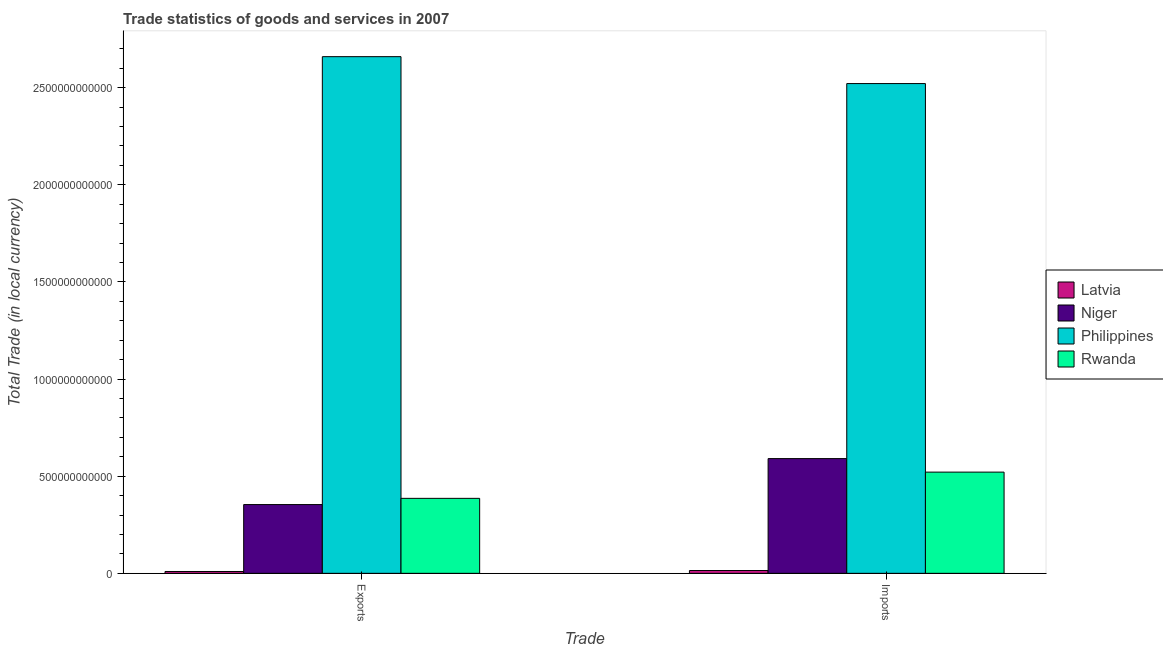How many groups of bars are there?
Your answer should be very brief. 2. Are the number of bars per tick equal to the number of legend labels?
Provide a short and direct response. Yes. How many bars are there on the 1st tick from the right?
Ensure brevity in your answer.  4. What is the label of the 1st group of bars from the left?
Make the answer very short. Exports. What is the export of goods and services in Philippines?
Your answer should be very brief. 2.66e+12. Across all countries, what is the maximum imports of goods and services?
Offer a very short reply. 2.52e+12. Across all countries, what is the minimum imports of goods and services?
Your answer should be very brief. 1.44e+1. In which country was the export of goods and services minimum?
Your answer should be compact. Latvia. What is the total export of goods and services in the graph?
Give a very brief answer. 3.41e+12. What is the difference between the export of goods and services in Latvia and that in Rwanda?
Keep it short and to the point. -3.76e+11. What is the difference between the imports of goods and services in Niger and the export of goods and services in Philippines?
Provide a short and direct response. -2.07e+12. What is the average export of goods and services per country?
Your answer should be compact. 8.52e+11. What is the difference between the imports of goods and services and export of goods and services in Rwanda?
Your answer should be compact. 1.35e+11. In how many countries, is the imports of goods and services greater than 1100000000000 LCU?
Ensure brevity in your answer.  1. What is the ratio of the export of goods and services in Philippines to that in Niger?
Keep it short and to the point. 7.51. Is the export of goods and services in Rwanda less than that in Niger?
Give a very brief answer. No. What does the 4th bar from the left in Exports represents?
Your answer should be compact. Rwanda. What does the 3rd bar from the right in Exports represents?
Offer a very short reply. Niger. What is the difference between two consecutive major ticks on the Y-axis?
Your response must be concise. 5.00e+11. Are the values on the major ticks of Y-axis written in scientific E-notation?
Ensure brevity in your answer.  No. Does the graph contain any zero values?
Provide a short and direct response. No. Where does the legend appear in the graph?
Provide a short and direct response. Center right. How many legend labels are there?
Keep it short and to the point. 4. How are the legend labels stacked?
Ensure brevity in your answer.  Vertical. What is the title of the graph?
Offer a very short reply. Trade statistics of goods and services in 2007. What is the label or title of the X-axis?
Offer a very short reply. Trade. What is the label or title of the Y-axis?
Offer a very short reply. Total Trade (in local currency). What is the Total Trade (in local currency) of Latvia in Exports?
Make the answer very short. 9.51e+09. What is the Total Trade (in local currency) in Niger in Exports?
Offer a very short reply. 3.54e+11. What is the Total Trade (in local currency) of Philippines in Exports?
Ensure brevity in your answer.  2.66e+12. What is the Total Trade (in local currency) in Rwanda in Exports?
Make the answer very short. 3.86e+11. What is the Total Trade (in local currency) of Latvia in Imports?
Ensure brevity in your answer.  1.44e+1. What is the Total Trade (in local currency) of Niger in Imports?
Provide a short and direct response. 5.91e+11. What is the Total Trade (in local currency) of Philippines in Imports?
Offer a terse response. 2.52e+12. What is the Total Trade (in local currency) of Rwanda in Imports?
Ensure brevity in your answer.  5.21e+11. Across all Trade, what is the maximum Total Trade (in local currency) in Latvia?
Keep it short and to the point. 1.44e+1. Across all Trade, what is the maximum Total Trade (in local currency) in Niger?
Your answer should be compact. 5.91e+11. Across all Trade, what is the maximum Total Trade (in local currency) of Philippines?
Ensure brevity in your answer.  2.66e+12. Across all Trade, what is the maximum Total Trade (in local currency) of Rwanda?
Give a very brief answer. 5.21e+11. Across all Trade, what is the minimum Total Trade (in local currency) of Latvia?
Give a very brief answer. 9.51e+09. Across all Trade, what is the minimum Total Trade (in local currency) in Niger?
Ensure brevity in your answer.  3.54e+11. Across all Trade, what is the minimum Total Trade (in local currency) of Philippines?
Your response must be concise. 2.52e+12. Across all Trade, what is the minimum Total Trade (in local currency) in Rwanda?
Provide a succinct answer. 3.86e+11. What is the total Total Trade (in local currency) in Latvia in the graph?
Offer a very short reply. 2.39e+1. What is the total Total Trade (in local currency) in Niger in the graph?
Provide a succinct answer. 9.45e+11. What is the total Total Trade (in local currency) of Philippines in the graph?
Your answer should be very brief. 5.18e+12. What is the total Total Trade (in local currency) of Rwanda in the graph?
Give a very brief answer. 9.07e+11. What is the difference between the Total Trade (in local currency) in Latvia in Exports and that in Imports?
Provide a short and direct response. -4.92e+09. What is the difference between the Total Trade (in local currency) in Niger in Exports and that in Imports?
Keep it short and to the point. -2.37e+11. What is the difference between the Total Trade (in local currency) in Philippines in Exports and that in Imports?
Provide a succinct answer. 1.39e+11. What is the difference between the Total Trade (in local currency) in Rwanda in Exports and that in Imports?
Provide a short and direct response. -1.35e+11. What is the difference between the Total Trade (in local currency) of Latvia in Exports and the Total Trade (in local currency) of Niger in Imports?
Provide a succinct answer. -5.81e+11. What is the difference between the Total Trade (in local currency) of Latvia in Exports and the Total Trade (in local currency) of Philippines in Imports?
Your answer should be very brief. -2.51e+12. What is the difference between the Total Trade (in local currency) of Latvia in Exports and the Total Trade (in local currency) of Rwanda in Imports?
Ensure brevity in your answer.  -5.11e+11. What is the difference between the Total Trade (in local currency) of Niger in Exports and the Total Trade (in local currency) of Philippines in Imports?
Make the answer very short. -2.17e+12. What is the difference between the Total Trade (in local currency) of Niger in Exports and the Total Trade (in local currency) of Rwanda in Imports?
Offer a very short reply. -1.67e+11. What is the difference between the Total Trade (in local currency) of Philippines in Exports and the Total Trade (in local currency) of Rwanda in Imports?
Your answer should be very brief. 2.14e+12. What is the average Total Trade (in local currency) of Latvia per Trade?
Your response must be concise. 1.20e+1. What is the average Total Trade (in local currency) of Niger per Trade?
Give a very brief answer. 4.72e+11. What is the average Total Trade (in local currency) of Philippines per Trade?
Your answer should be compact. 2.59e+12. What is the average Total Trade (in local currency) of Rwanda per Trade?
Make the answer very short. 4.54e+11. What is the difference between the Total Trade (in local currency) of Latvia and Total Trade (in local currency) of Niger in Exports?
Your answer should be compact. -3.44e+11. What is the difference between the Total Trade (in local currency) in Latvia and Total Trade (in local currency) in Philippines in Exports?
Offer a very short reply. -2.65e+12. What is the difference between the Total Trade (in local currency) in Latvia and Total Trade (in local currency) in Rwanda in Exports?
Offer a very short reply. -3.76e+11. What is the difference between the Total Trade (in local currency) in Niger and Total Trade (in local currency) in Philippines in Exports?
Your answer should be very brief. -2.31e+12. What is the difference between the Total Trade (in local currency) of Niger and Total Trade (in local currency) of Rwanda in Exports?
Make the answer very short. -3.20e+1. What is the difference between the Total Trade (in local currency) of Philippines and Total Trade (in local currency) of Rwanda in Exports?
Ensure brevity in your answer.  2.27e+12. What is the difference between the Total Trade (in local currency) of Latvia and Total Trade (in local currency) of Niger in Imports?
Give a very brief answer. -5.76e+11. What is the difference between the Total Trade (in local currency) of Latvia and Total Trade (in local currency) of Philippines in Imports?
Give a very brief answer. -2.51e+12. What is the difference between the Total Trade (in local currency) of Latvia and Total Trade (in local currency) of Rwanda in Imports?
Keep it short and to the point. -5.07e+11. What is the difference between the Total Trade (in local currency) in Niger and Total Trade (in local currency) in Philippines in Imports?
Provide a succinct answer. -1.93e+12. What is the difference between the Total Trade (in local currency) of Niger and Total Trade (in local currency) of Rwanda in Imports?
Offer a very short reply. 6.96e+1. What is the difference between the Total Trade (in local currency) in Philippines and Total Trade (in local currency) in Rwanda in Imports?
Keep it short and to the point. 2.00e+12. What is the ratio of the Total Trade (in local currency) of Latvia in Exports to that in Imports?
Offer a terse response. 0.66. What is the ratio of the Total Trade (in local currency) of Niger in Exports to that in Imports?
Your answer should be compact. 0.6. What is the ratio of the Total Trade (in local currency) in Philippines in Exports to that in Imports?
Your answer should be compact. 1.05. What is the ratio of the Total Trade (in local currency) of Rwanda in Exports to that in Imports?
Make the answer very short. 0.74. What is the difference between the highest and the second highest Total Trade (in local currency) of Latvia?
Your response must be concise. 4.92e+09. What is the difference between the highest and the second highest Total Trade (in local currency) of Niger?
Give a very brief answer. 2.37e+11. What is the difference between the highest and the second highest Total Trade (in local currency) of Philippines?
Your answer should be compact. 1.39e+11. What is the difference between the highest and the second highest Total Trade (in local currency) of Rwanda?
Provide a short and direct response. 1.35e+11. What is the difference between the highest and the lowest Total Trade (in local currency) in Latvia?
Your response must be concise. 4.92e+09. What is the difference between the highest and the lowest Total Trade (in local currency) of Niger?
Your answer should be very brief. 2.37e+11. What is the difference between the highest and the lowest Total Trade (in local currency) of Philippines?
Ensure brevity in your answer.  1.39e+11. What is the difference between the highest and the lowest Total Trade (in local currency) of Rwanda?
Provide a succinct answer. 1.35e+11. 